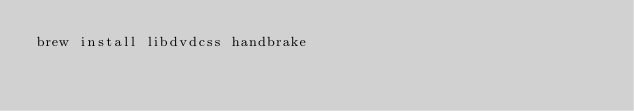Convert code to text. <code><loc_0><loc_0><loc_500><loc_500><_Bash_>brew install libdvdcss handbrake</code> 